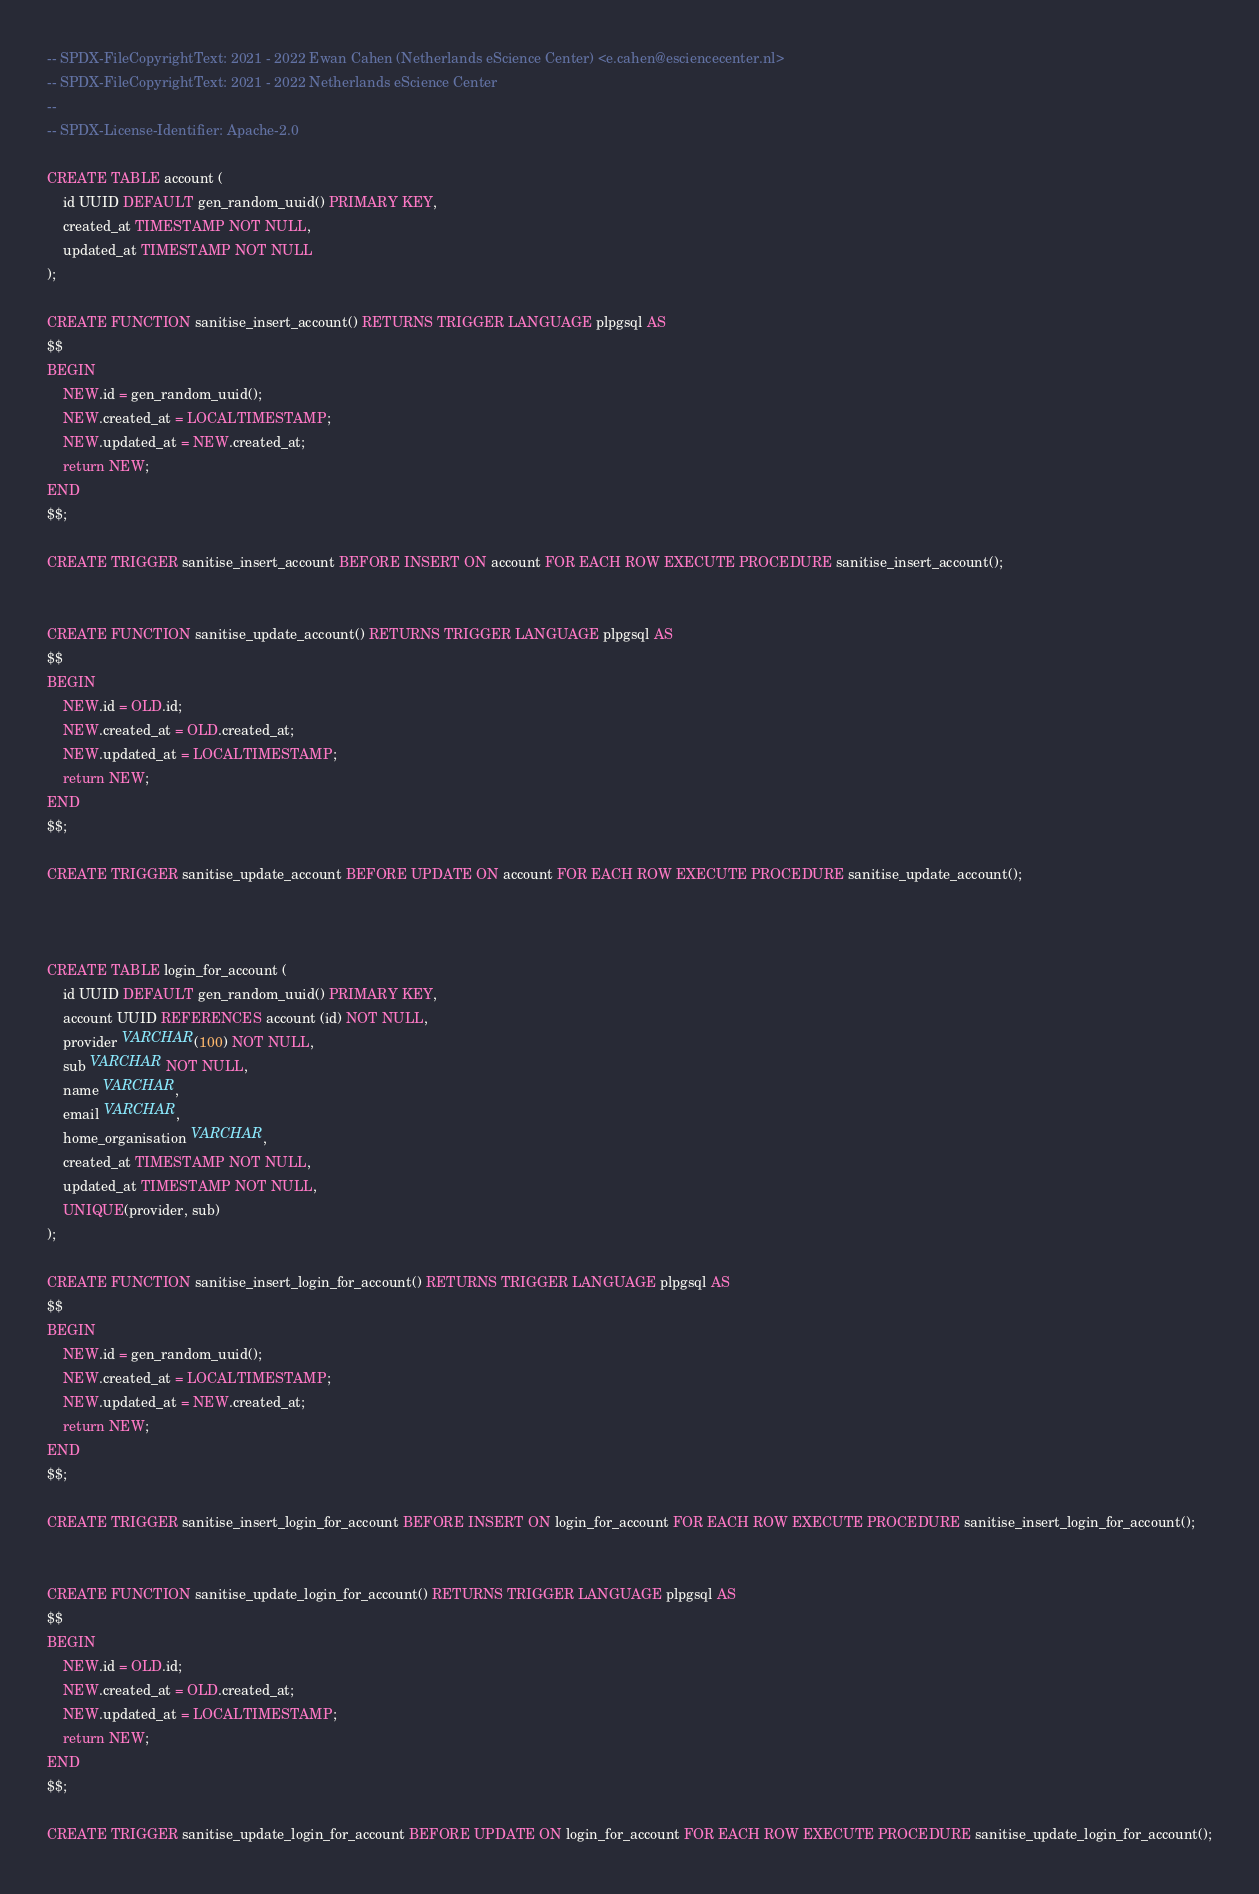<code> <loc_0><loc_0><loc_500><loc_500><_SQL_>-- SPDX-FileCopyrightText: 2021 - 2022 Ewan Cahen (Netherlands eScience Center) <e.cahen@esciencecenter.nl>
-- SPDX-FileCopyrightText: 2021 - 2022 Netherlands eScience Center
--
-- SPDX-License-Identifier: Apache-2.0

CREATE TABLE account (
	id UUID DEFAULT gen_random_uuid() PRIMARY KEY,
	created_at TIMESTAMP NOT NULL,
	updated_at TIMESTAMP NOT NULL
);

CREATE FUNCTION sanitise_insert_account() RETURNS TRIGGER LANGUAGE plpgsql AS
$$
BEGIN
	NEW.id = gen_random_uuid();
	NEW.created_at = LOCALTIMESTAMP;
	NEW.updated_at = NEW.created_at;
	return NEW;
END
$$;

CREATE TRIGGER sanitise_insert_account BEFORE INSERT ON account FOR EACH ROW EXECUTE PROCEDURE sanitise_insert_account();


CREATE FUNCTION sanitise_update_account() RETURNS TRIGGER LANGUAGE plpgsql AS
$$
BEGIN
	NEW.id = OLD.id;
	NEW.created_at = OLD.created_at;
	NEW.updated_at = LOCALTIMESTAMP;
	return NEW;
END
$$;

CREATE TRIGGER sanitise_update_account BEFORE UPDATE ON account FOR EACH ROW EXECUTE PROCEDURE sanitise_update_account();



CREATE TABLE login_for_account (
	id UUID DEFAULT gen_random_uuid() PRIMARY KEY,
	account UUID REFERENCES account (id) NOT NULL,
	provider VARCHAR(100) NOT NULL,
	sub VARCHAR NOT NULL,
	name VARCHAR,
	email VARCHAR,
	home_organisation VARCHAR,
	created_at TIMESTAMP NOT NULL,
	updated_at TIMESTAMP NOT NULL,
	UNIQUE(provider, sub)
);

CREATE FUNCTION sanitise_insert_login_for_account() RETURNS TRIGGER LANGUAGE plpgsql AS
$$
BEGIN
	NEW.id = gen_random_uuid();
	NEW.created_at = LOCALTIMESTAMP;
	NEW.updated_at = NEW.created_at;
	return NEW;
END
$$;

CREATE TRIGGER sanitise_insert_login_for_account BEFORE INSERT ON login_for_account FOR EACH ROW EXECUTE PROCEDURE sanitise_insert_login_for_account();


CREATE FUNCTION sanitise_update_login_for_account() RETURNS TRIGGER LANGUAGE plpgsql AS
$$
BEGIN
	NEW.id = OLD.id;
	NEW.created_at = OLD.created_at;
	NEW.updated_at = LOCALTIMESTAMP;
	return NEW;
END
$$;

CREATE TRIGGER sanitise_update_login_for_account BEFORE UPDATE ON login_for_account FOR EACH ROW EXECUTE PROCEDURE sanitise_update_login_for_account();
</code> 